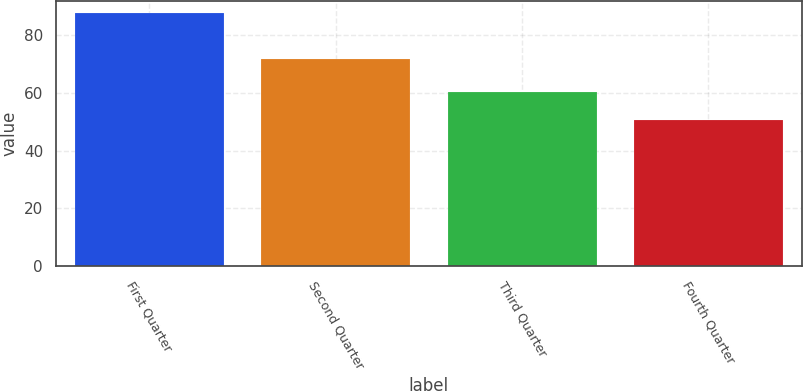Convert chart to OTSL. <chart><loc_0><loc_0><loc_500><loc_500><bar_chart><fcel>First Quarter<fcel>Second Quarter<fcel>Third Quarter<fcel>Fourth Quarter<nl><fcel>87.7<fcel>71.76<fcel>60.5<fcel>50.55<nl></chart> 